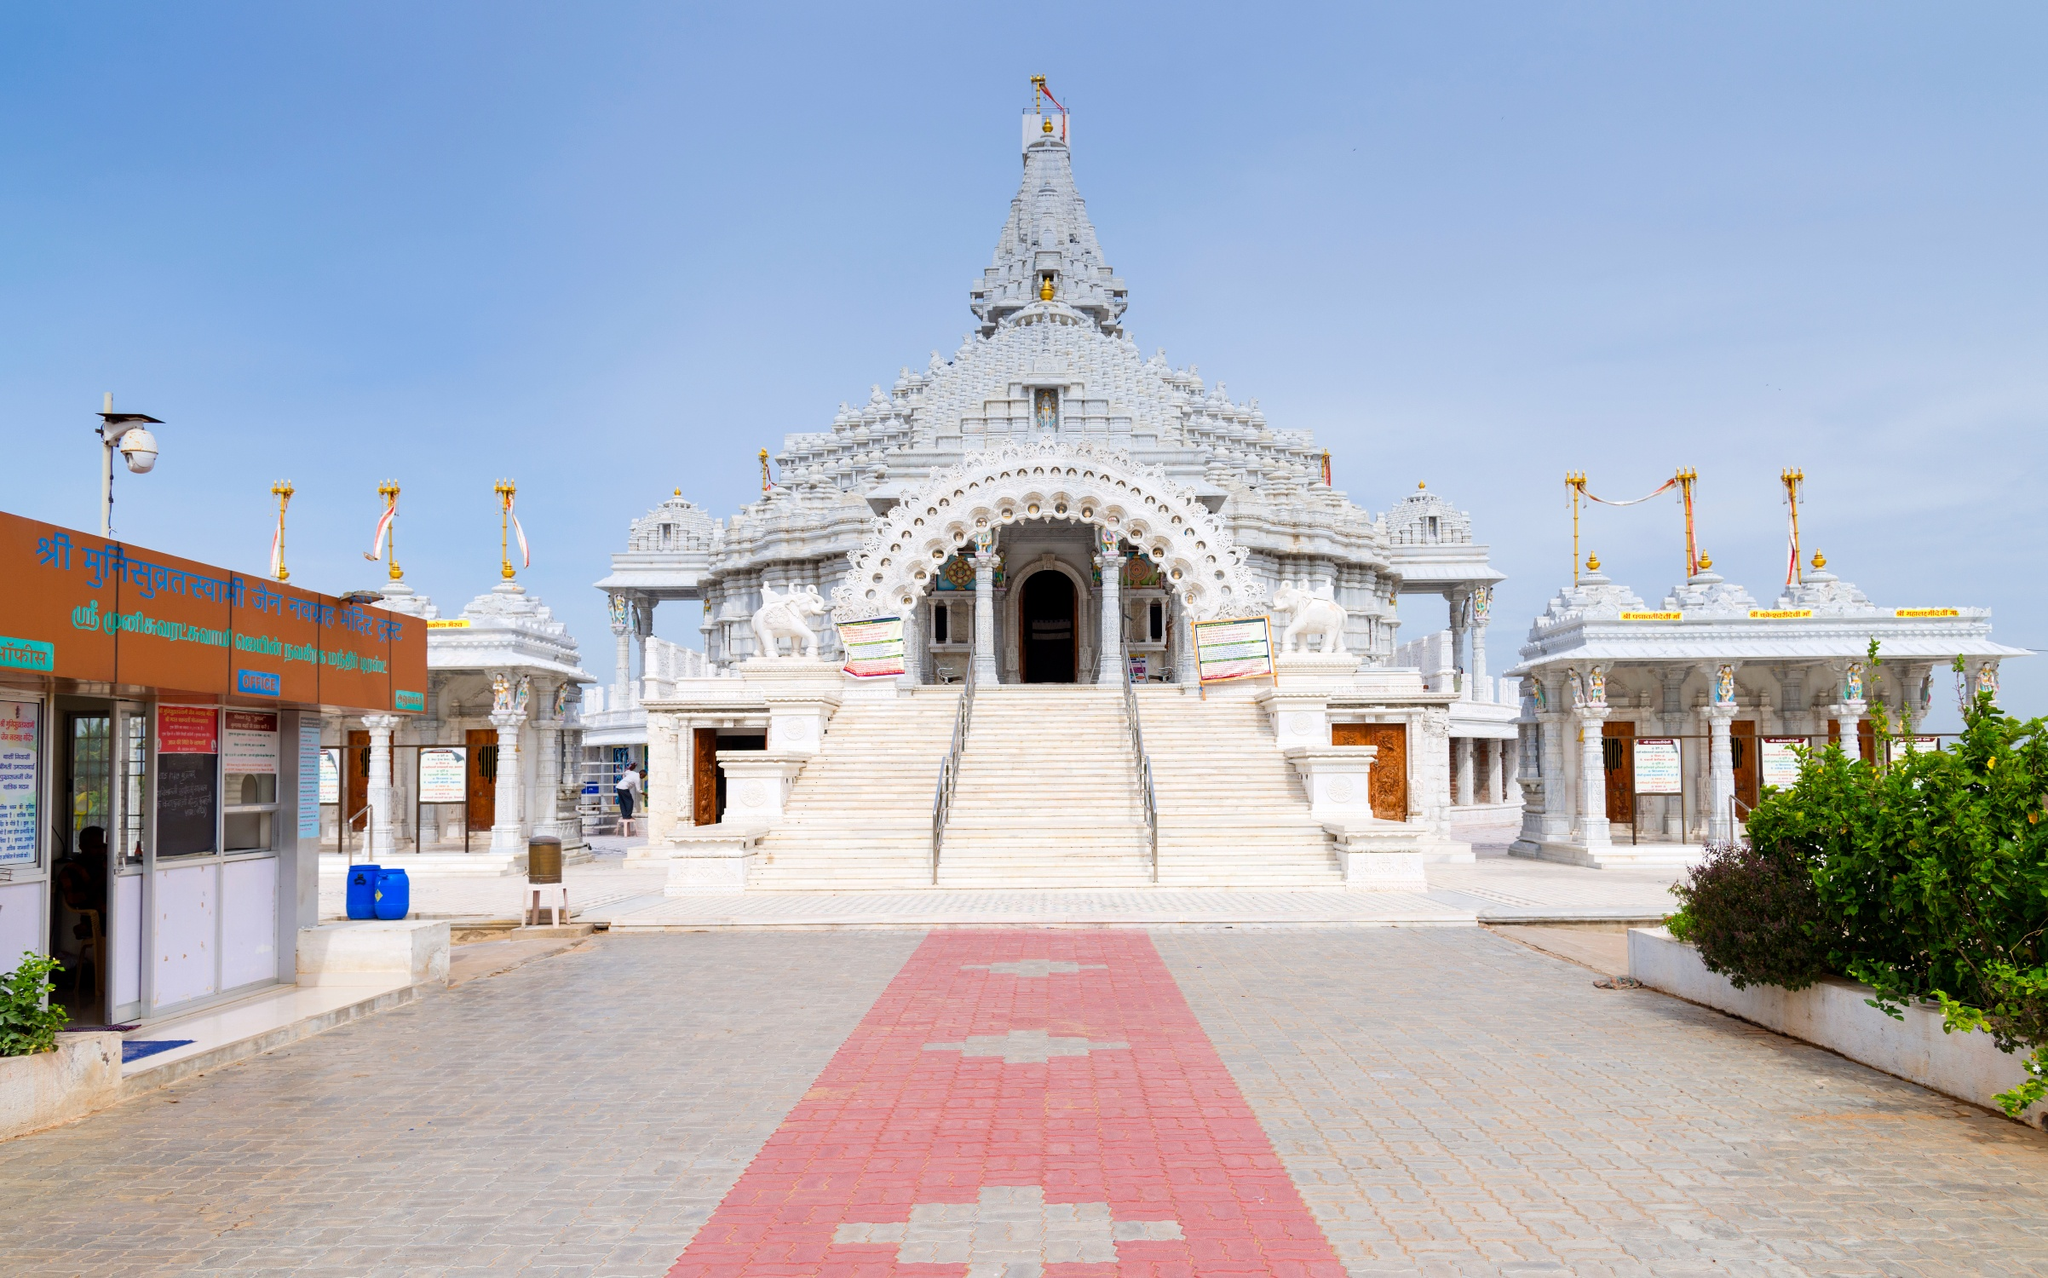What is the significance of the flag on top of the temple? In Hindu temple architecture, the flag flown atop the temple, known as the 'Dhvaja' or 'flag', is deeply symbolic. It typically represents the temple's patron deity and serves as a reminder of the divine presence within. The flag is often hoisted during special occasions and festivals, signifying victory and protection. Although we can't confirm the exact symbolism for this temple without additional context, such flags are generally a symbol of hope, faith, and communal identity among devotees. 